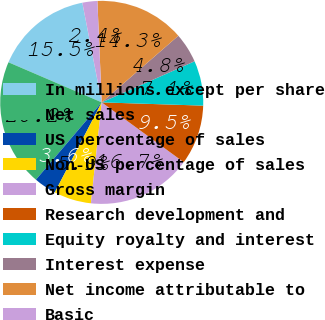Convert chart. <chart><loc_0><loc_0><loc_500><loc_500><pie_chart><fcel>In millions except per share<fcel>Net sales<fcel>US percentage of sales<fcel>Non-US percentage of sales<fcel>Gross margin<fcel>Research development and<fcel>Equity royalty and interest<fcel>Interest expense<fcel>Net income attributable to<fcel>Basic<nl><fcel>15.48%<fcel>20.24%<fcel>3.57%<fcel>5.95%<fcel>16.67%<fcel>9.52%<fcel>7.14%<fcel>4.76%<fcel>14.29%<fcel>2.38%<nl></chart> 